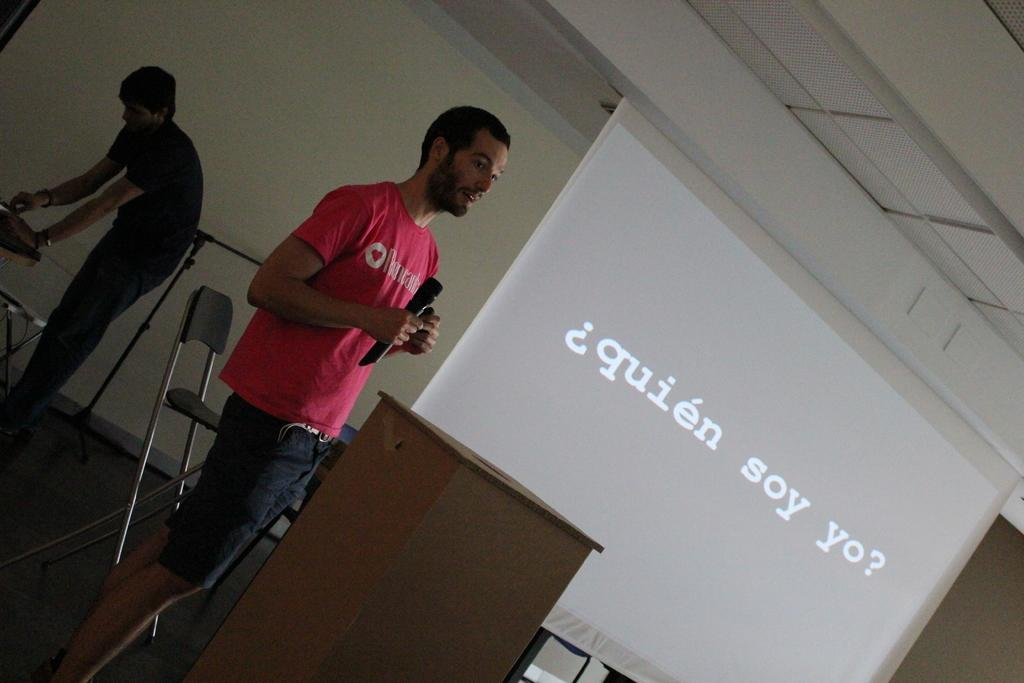What is the man in the image holding? The man is holding a mic. What is the man's position in the image? The man is standing on the floor. Can you describe the background of the image? There is a person, a podium, a chair, a stand, a screen, and a wall visible in the background. What type of chalk is the man using to write on the wheel in the image? There is no wheel or chalk present in the image. Is the event taking place during the night or day in the image? The time of day cannot be determined from the image, as there is no information about lighting or shadows. 